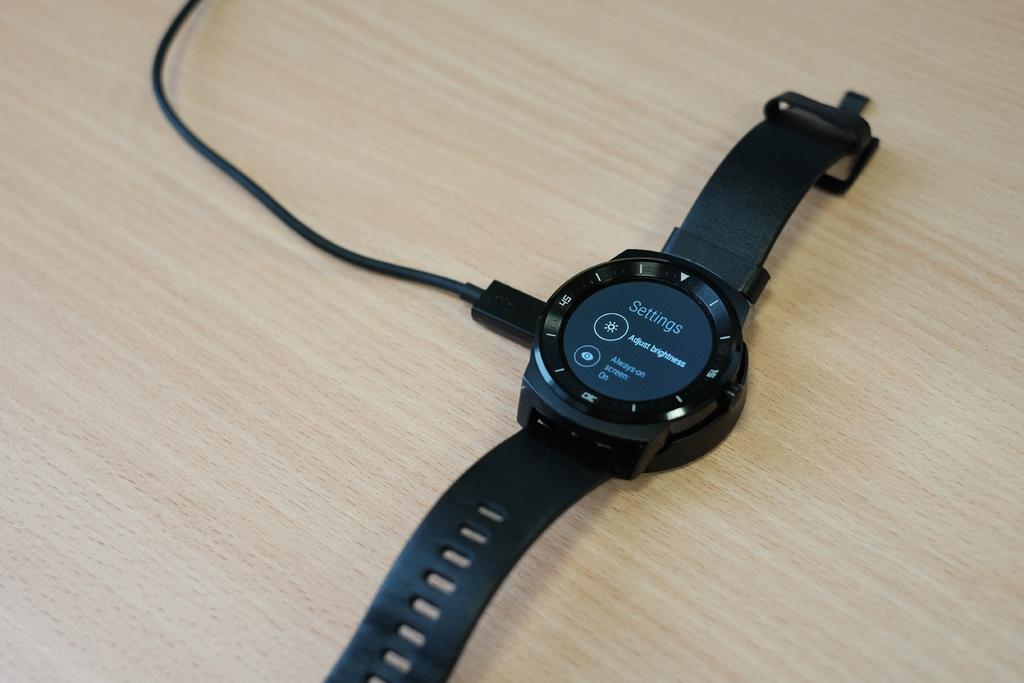What type of furniture is present in the image? There is a table in the image. What object can be seen on the table? There is a black color watch on the table. What else is on the table besides the watch? There is a wire on the table. What type of seed is growing on the sidewalk in the image? There is no sidewalk or seed present in the image. 